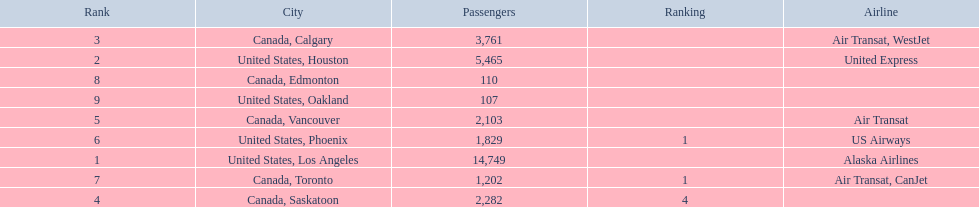What are all the cities? United States, Los Angeles, United States, Houston, Canada, Calgary, Canada, Saskatoon, Canada, Vancouver, United States, Phoenix, Canada, Toronto, Canada, Edmonton, United States, Oakland. I'm looking to parse the entire table for insights. Could you assist me with that? {'header': ['Rank', 'City', 'Passengers', 'Ranking', 'Airline'], 'rows': [['3', 'Canada, Calgary', '3,761', '', 'Air Transat, WestJet'], ['2', 'United States, Houston', '5,465', '', 'United Express'], ['8', 'Canada, Edmonton', '110', '', ''], ['9', 'United States, Oakland', '107', '', ''], ['5', 'Canada, Vancouver', '2,103', '', 'Air Transat'], ['6', 'United States, Phoenix', '1,829', '1', 'US Airways'], ['1', 'United States, Los Angeles', '14,749', '', 'Alaska Airlines'], ['7', 'Canada, Toronto', '1,202', '1', 'Air Transat, CanJet'], ['4', 'Canada, Saskatoon', '2,282', '4', '']]} How many passengers do they service? 14,749, 5,465, 3,761, 2,282, 2,103, 1,829, 1,202, 110, 107. Which city, when combined with los angeles, totals nearly 19,000? Canada, Calgary. 